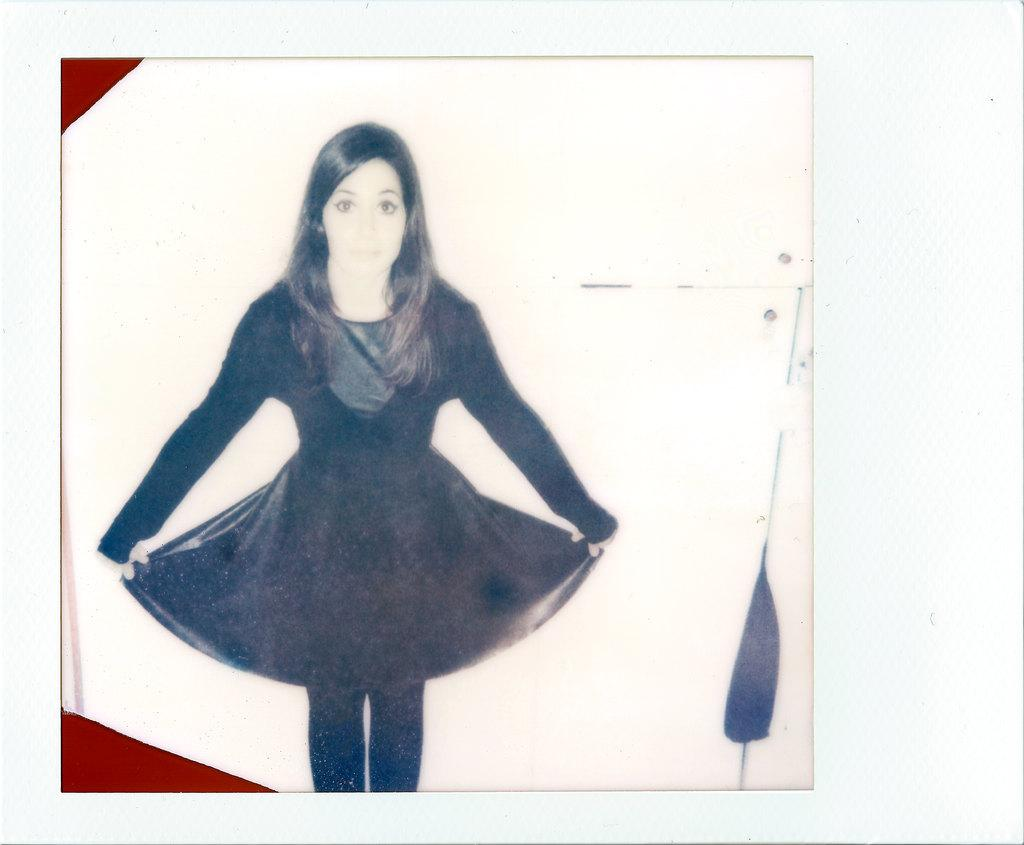What is one of the main features in the image? There is a wall in the image. What is attached to the wall in the image? There is a photo frame in the image. What can be seen inside the photo frame? The photo frame contains an image of a woman. What is the woman in the photo wearing? The woman in the photo is wearing a black dress. What type of advertisement can be seen on the wall in the image? There is no advertisement present on the wall in the image; it only features a photo frame with an image of a woman. Can you read the letter that is visible in the image? There is no letter present in the image; it only features a photo frame with an image of a woman. 